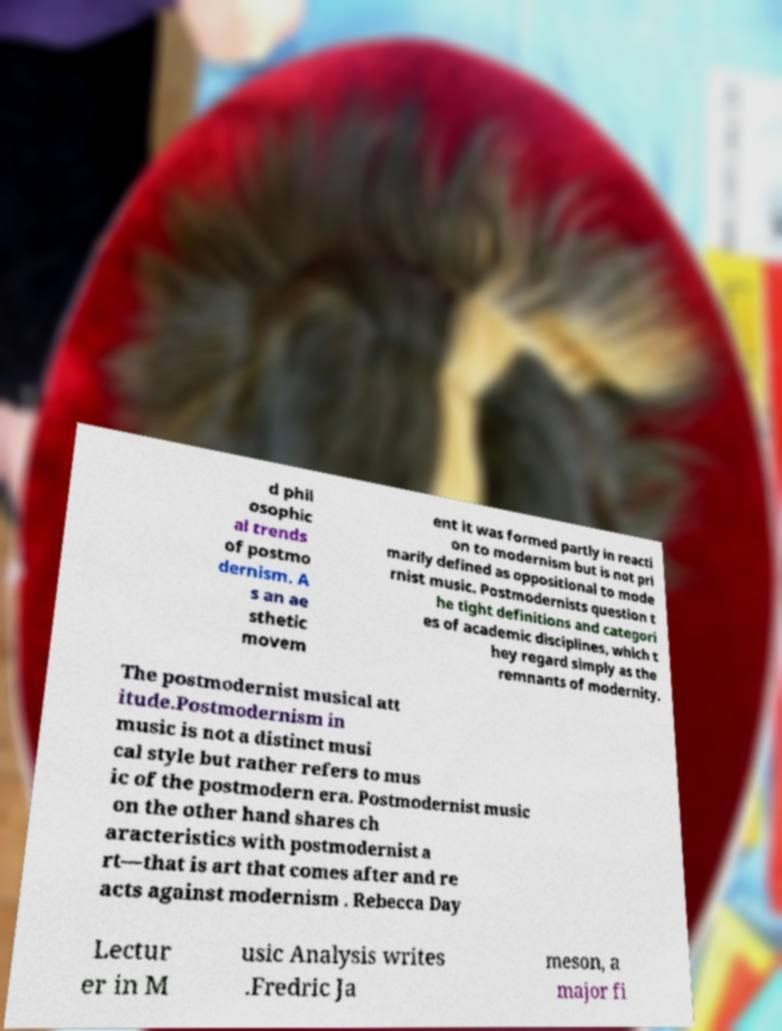Can you read and provide the text displayed in the image?This photo seems to have some interesting text. Can you extract and type it out for me? d phil osophic al trends of postmo dernism. A s an ae sthetic movem ent it was formed partly in reacti on to modernism but is not pri marily defined as oppositional to mode rnist music. Postmodernists question t he tight definitions and categori es of academic disciplines, which t hey regard simply as the remnants of modernity. The postmodernist musical att itude.Postmodernism in music is not a distinct musi cal style but rather refers to mus ic of the postmodern era. Postmodernist music on the other hand shares ch aracteristics with postmodernist a rt—that is art that comes after and re acts against modernism . Rebecca Day Lectur er in M usic Analysis writes .Fredric Ja meson, a major fi 